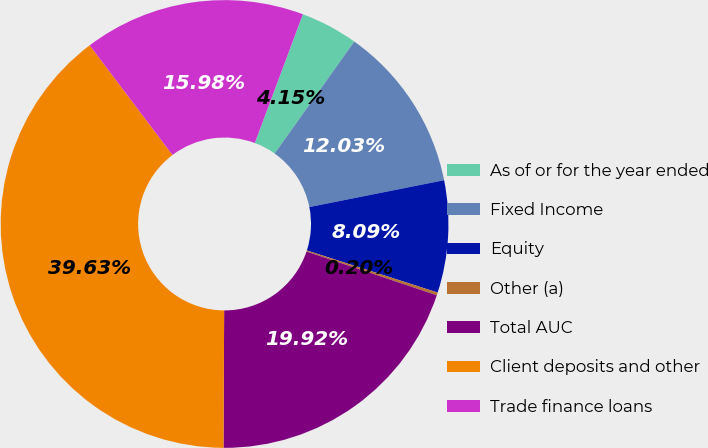Convert chart to OTSL. <chart><loc_0><loc_0><loc_500><loc_500><pie_chart><fcel>As of or for the year ended<fcel>Fixed Income<fcel>Equity<fcel>Other (a)<fcel>Total AUC<fcel>Client deposits and other<fcel>Trade finance loans<nl><fcel>4.15%<fcel>12.03%<fcel>8.09%<fcel>0.2%<fcel>19.92%<fcel>39.63%<fcel>15.98%<nl></chart> 